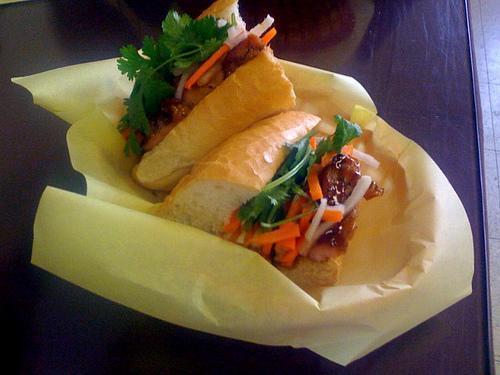How many pieces are there?
Give a very brief answer. 2. How many pieces of sandwich are on the paper?
Give a very brief answer. 2. How many sandwiches can you see?
Give a very brief answer. 2. How many bikes are in the photo?
Give a very brief answer. 0. 